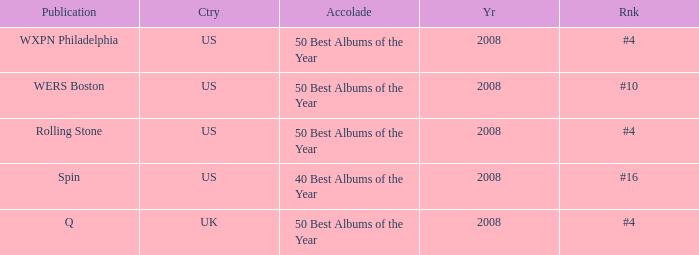Which year's rank was #4 when the country was the US? 2008, 2008. 